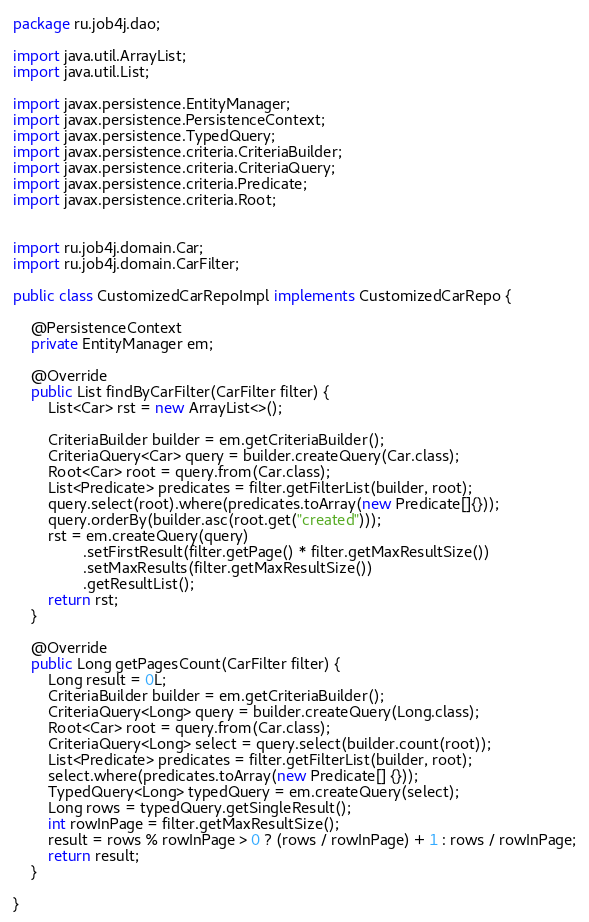Convert code to text. <code><loc_0><loc_0><loc_500><loc_500><_Java_>package ru.job4j.dao;

import java.util.ArrayList;
import java.util.List;

import javax.persistence.EntityManager;
import javax.persistence.PersistenceContext;
import javax.persistence.TypedQuery;
import javax.persistence.criteria.CriteriaBuilder;
import javax.persistence.criteria.CriteriaQuery;
import javax.persistence.criteria.Predicate;
import javax.persistence.criteria.Root;


import ru.job4j.domain.Car;
import ru.job4j.domain.CarFilter;

public class CustomizedCarRepoImpl implements CustomizedCarRepo {

	@PersistenceContext
    private EntityManager em;

	@Override
	public List findByCarFilter(CarFilter filter) {
		List<Car> rst = new ArrayList<>();
	              
		CriteriaBuilder builder = em.getCriteriaBuilder();
        CriteriaQuery<Car> query = builder.createQuery(Car.class);
        Root<Car> root = query.from(Car.class);
        List<Predicate> predicates = filter.getFilterList(builder, root);
        query.select(root).where(predicates.toArray(new Predicate[]{}));
		query.orderBy(builder.asc(root.get("created")));
		rst = em.createQuery(query)
        		.setFirstResult(filter.getPage() * filter.getMaxResultSize())
        		.setMaxResults(filter.getMaxResultSize())
        		.getResultList();
		return rst;
	}

	@Override
	public Long getPagesCount(CarFilter filter) {
		Long result = 0L;
		CriteriaBuilder builder = em.getCriteriaBuilder();
		CriteriaQuery<Long> query = builder.createQuery(Long.class);
		Root<Car> root = query.from(Car.class);
		CriteriaQuery<Long> select = query.select(builder.count(root));
		List<Predicate> predicates = filter.getFilterList(builder, root);
		select.where(predicates.toArray(new Predicate[] {}));
		TypedQuery<Long> typedQuery = em.createQuery(select);
		Long rows = typedQuery.getSingleResult();
		int rowInPage = filter.getMaxResultSize();
		result = rows % rowInPage > 0 ? (rows / rowInPage) + 1 : rows / rowInPage;
		return result;
	}
	
}
</code> 